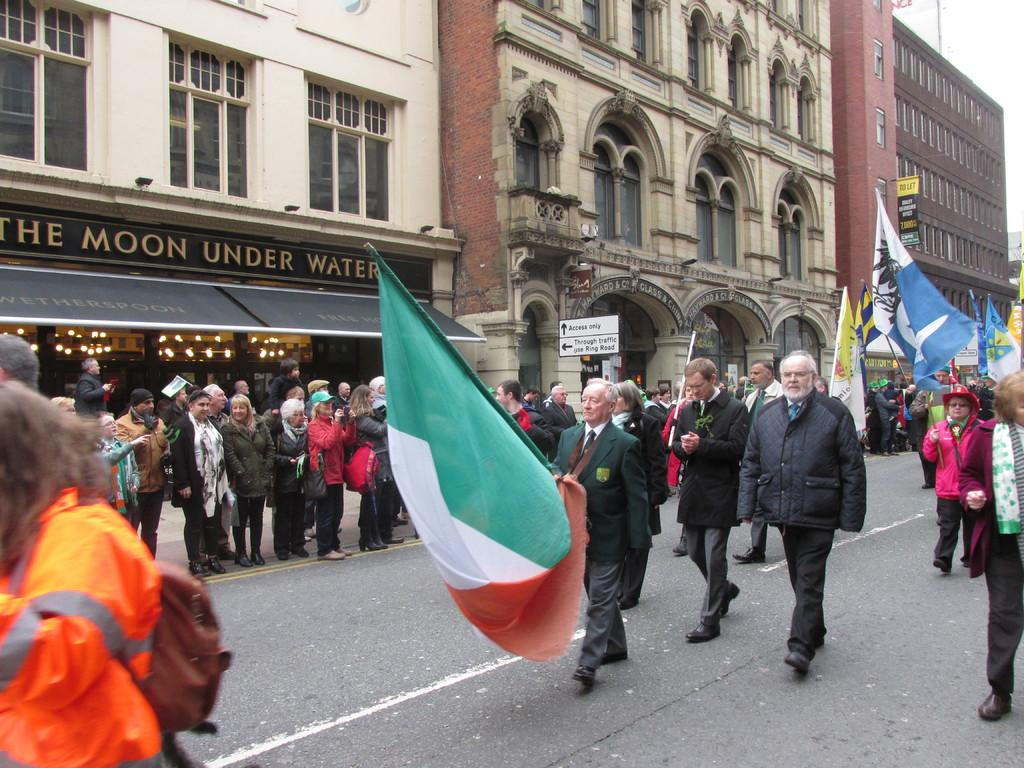What are the people in the image doing? Some people are walking on the road, while others are standing in the image. Are there any objects being held by the people in the image? Yes, some people are holding flags in the image. What can be seen in the background of the image? There are buildings in the background of the image. What type of quilt is being used to cover the representative in the image? There is no quilt or representative present in the image; it features people walking, standing, and holding flags. 